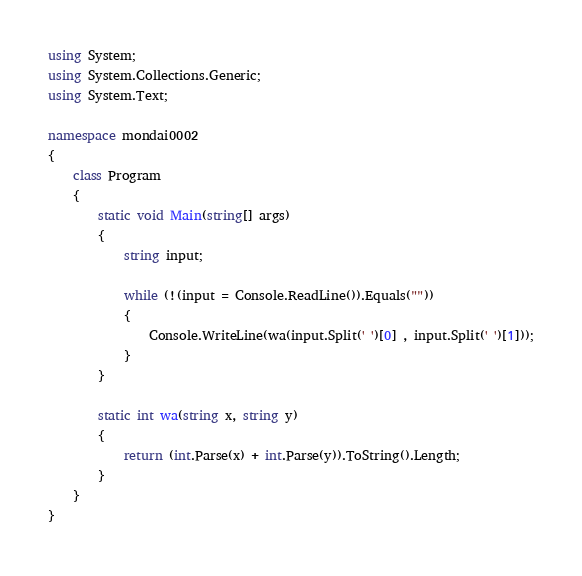Convert code to text. <code><loc_0><loc_0><loc_500><loc_500><_C#_>using System;
using System.Collections.Generic;
using System.Text;

namespace mondai0002
{
    class Program
    {
        static void Main(string[] args)
        {
            string input;

            while (!(input = Console.ReadLine()).Equals(""))
            {
                Console.WriteLine(wa(input.Split(' ')[0] , input.Split(' ')[1]));
            }
        }

        static int wa(string x, string y)
        {
            return (int.Parse(x) + int.Parse(y)).ToString().Length;
        }
    }
}</code> 